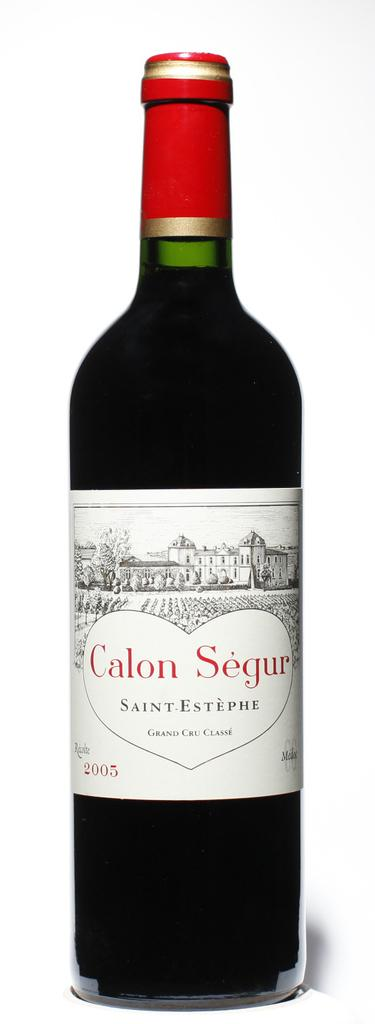<image>
Relay a brief, clear account of the picture shown. A bottle of Calon Segur has a red top on ot. 